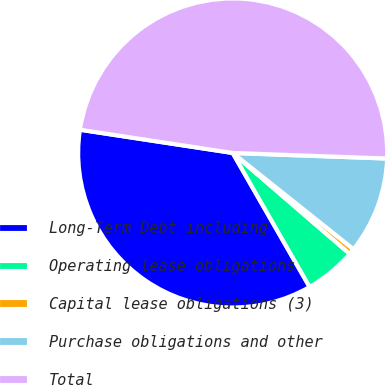<chart> <loc_0><loc_0><loc_500><loc_500><pie_chart><fcel>Long-Term Debt including<fcel>Operating lease obligations<fcel>Capital lease obligations (3)<fcel>Purchase obligations and other<fcel>Total<nl><fcel>35.7%<fcel>5.38%<fcel>0.62%<fcel>10.13%<fcel>48.17%<nl></chart> 